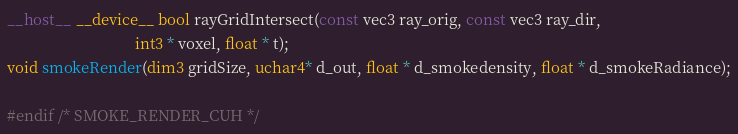<code> <loc_0><loc_0><loc_500><loc_500><_Cuda_>__host__ __device__ bool rayGridIntersect(const vec3 ray_orig, const vec3 ray_dir, 
                                 int3 * voxel, float * t);
void smokeRender(dim3 gridSize, uchar4* d_out, float * d_smokedensity, float * d_smokeRadiance);

#endif /* SMOKE_RENDER_CUH */
</code> 